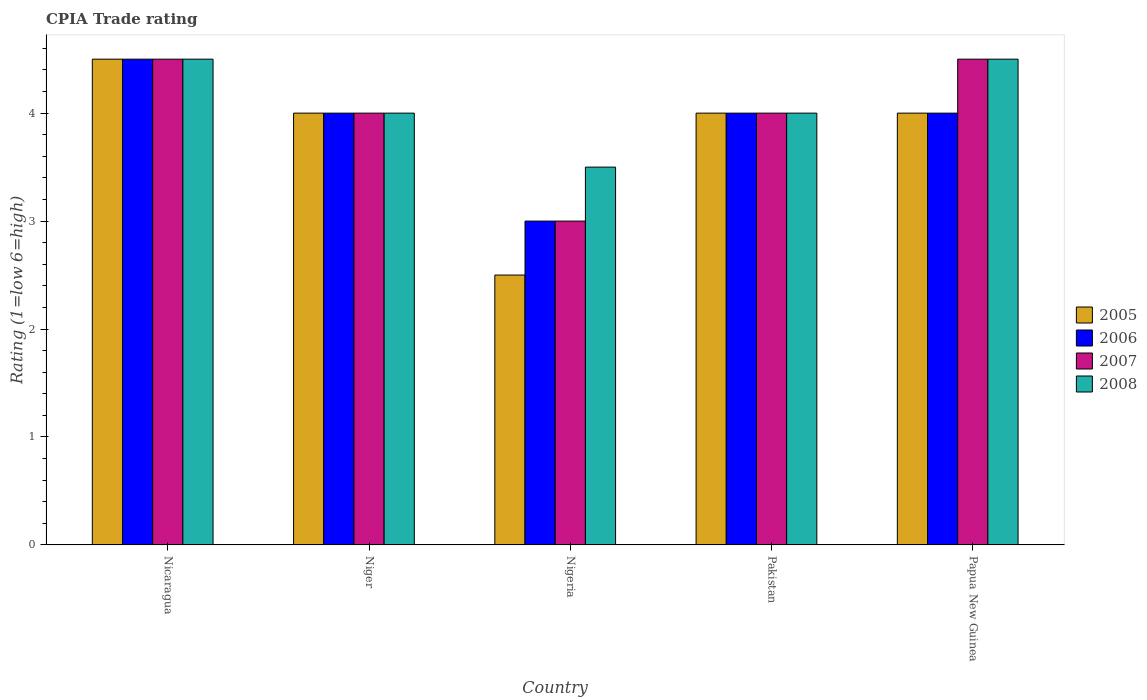How many bars are there on the 1st tick from the left?
Provide a succinct answer. 4. How many bars are there on the 2nd tick from the right?
Keep it short and to the point. 4. What is the label of the 5th group of bars from the left?
Make the answer very short. Papua New Guinea. In how many cases, is the number of bars for a given country not equal to the number of legend labels?
Provide a succinct answer. 0. In which country was the CPIA rating in 2008 maximum?
Make the answer very short. Nicaragua. In which country was the CPIA rating in 2008 minimum?
Give a very brief answer. Nigeria. What is the difference between the CPIA rating in 2006 in Papua New Guinea and the CPIA rating in 2008 in Nicaragua?
Provide a short and direct response. -0.5. What is the difference between the CPIA rating of/in 2006 and CPIA rating of/in 2007 in Pakistan?
Your response must be concise. 0. What is the ratio of the CPIA rating in 2005 in Nicaragua to that in Niger?
Your answer should be very brief. 1.12. Is the difference between the CPIA rating in 2006 in Nicaragua and Niger greater than the difference between the CPIA rating in 2007 in Nicaragua and Niger?
Provide a short and direct response. No. What is the difference between the highest and the second highest CPIA rating in 2007?
Provide a short and direct response. 0.5. In how many countries, is the CPIA rating in 2008 greater than the average CPIA rating in 2008 taken over all countries?
Provide a short and direct response. 2. Is the sum of the CPIA rating in 2005 in Nicaragua and Pakistan greater than the maximum CPIA rating in 2006 across all countries?
Your answer should be very brief. Yes. Is it the case that in every country, the sum of the CPIA rating in 2007 and CPIA rating in 2005 is greater than the sum of CPIA rating in 2008 and CPIA rating in 2006?
Your response must be concise. No. What does the 2nd bar from the left in Pakistan represents?
Your answer should be very brief. 2006. Is it the case that in every country, the sum of the CPIA rating in 2007 and CPIA rating in 2006 is greater than the CPIA rating in 2005?
Provide a succinct answer. Yes. How many bars are there?
Provide a succinct answer. 20. Are all the bars in the graph horizontal?
Ensure brevity in your answer.  No. How many countries are there in the graph?
Give a very brief answer. 5. What is the difference between two consecutive major ticks on the Y-axis?
Your answer should be compact. 1. Are the values on the major ticks of Y-axis written in scientific E-notation?
Offer a terse response. No. Does the graph contain grids?
Your answer should be compact. No. How many legend labels are there?
Offer a terse response. 4. How are the legend labels stacked?
Keep it short and to the point. Vertical. What is the title of the graph?
Offer a very short reply. CPIA Trade rating. Does "2009" appear as one of the legend labels in the graph?
Provide a short and direct response. No. What is the label or title of the Y-axis?
Offer a very short reply. Rating (1=low 6=high). What is the Rating (1=low 6=high) in 2005 in Nicaragua?
Your answer should be very brief. 4.5. What is the Rating (1=low 6=high) of 2006 in Nicaragua?
Make the answer very short. 4.5. What is the Rating (1=low 6=high) in 2008 in Nicaragua?
Your answer should be compact. 4.5. What is the Rating (1=low 6=high) of 2008 in Niger?
Give a very brief answer. 4. What is the Rating (1=low 6=high) of 2005 in Nigeria?
Provide a succinct answer. 2.5. What is the Rating (1=low 6=high) of 2006 in Nigeria?
Provide a succinct answer. 3. What is the Rating (1=low 6=high) in 2007 in Pakistan?
Your answer should be very brief. 4. What is the Rating (1=low 6=high) in 2005 in Papua New Guinea?
Your response must be concise. 4. What is the Rating (1=low 6=high) of 2008 in Papua New Guinea?
Give a very brief answer. 4.5. Across all countries, what is the maximum Rating (1=low 6=high) of 2008?
Your response must be concise. 4.5. Across all countries, what is the minimum Rating (1=low 6=high) of 2006?
Ensure brevity in your answer.  3. Across all countries, what is the minimum Rating (1=low 6=high) of 2008?
Give a very brief answer. 3.5. What is the total Rating (1=low 6=high) in 2008 in the graph?
Give a very brief answer. 20.5. What is the difference between the Rating (1=low 6=high) in 2005 in Nicaragua and that in Niger?
Your answer should be compact. 0.5. What is the difference between the Rating (1=low 6=high) of 2007 in Nicaragua and that in Niger?
Provide a succinct answer. 0.5. What is the difference between the Rating (1=low 6=high) of 2005 in Nicaragua and that in Nigeria?
Make the answer very short. 2. What is the difference between the Rating (1=low 6=high) in 2006 in Nicaragua and that in Nigeria?
Keep it short and to the point. 1.5. What is the difference between the Rating (1=low 6=high) of 2007 in Nicaragua and that in Nigeria?
Your answer should be very brief. 1.5. What is the difference between the Rating (1=low 6=high) in 2008 in Nicaragua and that in Pakistan?
Offer a terse response. 0.5. What is the difference between the Rating (1=low 6=high) of 2008 in Nicaragua and that in Papua New Guinea?
Ensure brevity in your answer.  0. What is the difference between the Rating (1=low 6=high) of 2006 in Niger and that in Nigeria?
Make the answer very short. 1. What is the difference between the Rating (1=low 6=high) in 2007 in Niger and that in Nigeria?
Give a very brief answer. 1. What is the difference between the Rating (1=low 6=high) in 2005 in Niger and that in Pakistan?
Provide a short and direct response. 0. What is the difference between the Rating (1=low 6=high) of 2007 in Niger and that in Pakistan?
Provide a short and direct response. 0. What is the difference between the Rating (1=low 6=high) of 2006 in Niger and that in Papua New Guinea?
Offer a very short reply. 0. What is the difference between the Rating (1=low 6=high) in 2005 in Nigeria and that in Pakistan?
Provide a succinct answer. -1.5. What is the difference between the Rating (1=low 6=high) in 2008 in Nigeria and that in Pakistan?
Give a very brief answer. -0.5. What is the difference between the Rating (1=low 6=high) of 2006 in Nigeria and that in Papua New Guinea?
Your response must be concise. -1. What is the difference between the Rating (1=low 6=high) of 2007 in Pakistan and that in Papua New Guinea?
Provide a succinct answer. -0.5. What is the difference between the Rating (1=low 6=high) in 2005 in Nicaragua and the Rating (1=low 6=high) in 2008 in Niger?
Your answer should be compact. 0.5. What is the difference between the Rating (1=low 6=high) in 2006 in Nicaragua and the Rating (1=low 6=high) in 2008 in Niger?
Your response must be concise. 0.5. What is the difference between the Rating (1=low 6=high) in 2005 in Nicaragua and the Rating (1=low 6=high) in 2006 in Nigeria?
Your response must be concise. 1.5. What is the difference between the Rating (1=low 6=high) of 2006 in Nicaragua and the Rating (1=low 6=high) of 2007 in Nigeria?
Make the answer very short. 1.5. What is the difference between the Rating (1=low 6=high) of 2006 in Nicaragua and the Rating (1=low 6=high) of 2008 in Nigeria?
Give a very brief answer. 1. What is the difference between the Rating (1=low 6=high) in 2007 in Nicaragua and the Rating (1=low 6=high) in 2008 in Nigeria?
Provide a succinct answer. 1. What is the difference between the Rating (1=low 6=high) of 2006 in Nicaragua and the Rating (1=low 6=high) of 2008 in Pakistan?
Your response must be concise. 0.5. What is the difference between the Rating (1=low 6=high) in 2005 in Nicaragua and the Rating (1=low 6=high) in 2006 in Papua New Guinea?
Make the answer very short. 0.5. What is the difference between the Rating (1=low 6=high) in 2005 in Nicaragua and the Rating (1=low 6=high) in 2008 in Papua New Guinea?
Provide a short and direct response. 0. What is the difference between the Rating (1=low 6=high) in 2006 in Nicaragua and the Rating (1=low 6=high) in 2007 in Papua New Guinea?
Provide a succinct answer. 0. What is the difference between the Rating (1=low 6=high) in 2006 in Nicaragua and the Rating (1=low 6=high) in 2008 in Papua New Guinea?
Ensure brevity in your answer.  0. What is the difference between the Rating (1=low 6=high) in 2007 in Nicaragua and the Rating (1=low 6=high) in 2008 in Papua New Guinea?
Your response must be concise. 0. What is the difference between the Rating (1=low 6=high) in 2005 in Niger and the Rating (1=low 6=high) in 2007 in Nigeria?
Keep it short and to the point. 1. What is the difference between the Rating (1=low 6=high) of 2005 in Niger and the Rating (1=low 6=high) of 2008 in Nigeria?
Keep it short and to the point. 0.5. What is the difference between the Rating (1=low 6=high) of 2005 in Niger and the Rating (1=low 6=high) of 2006 in Pakistan?
Your answer should be very brief. 0. What is the difference between the Rating (1=low 6=high) of 2005 in Niger and the Rating (1=low 6=high) of 2007 in Pakistan?
Ensure brevity in your answer.  0. What is the difference between the Rating (1=low 6=high) of 2007 in Niger and the Rating (1=low 6=high) of 2008 in Pakistan?
Make the answer very short. 0. What is the difference between the Rating (1=low 6=high) of 2006 in Niger and the Rating (1=low 6=high) of 2007 in Papua New Guinea?
Your response must be concise. -0.5. What is the difference between the Rating (1=low 6=high) of 2007 in Niger and the Rating (1=low 6=high) of 2008 in Papua New Guinea?
Offer a very short reply. -0.5. What is the difference between the Rating (1=low 6=high) in 2005 in Nigeria and the Rating (1=low 6=high) in 2006 in Pakistan?
Your answer should be compact. -1.5. What is the difference between the Rating (1=low 6=high) in 2005 in Nigeria and the Rating (1=low 6=high) in 2007 in Pakistan?
Your response must be concise. -1.5. What is the difference between the Rating (1=low 6=high) in 2006 in Nigeria and the Rating (1=low 6=high) in 2007 in Pakistan?
Your answer should be compact. -1. What is the difference between the Rating (1=low 6=high) of 2007 in Nigeria and the Rating (1=low 6=high) of 2008 in Pakistan?
Offer a very short reply. -1. What is the difference between the Rating (1=low 6=high) of 2006 in Nigeria and the Rating (1=low 6=high) of 2007 in Papua New Guinea?
Provide a short and direct response. -1.5. What is the difference between the Rating (1=low 6=high) of 2007 in Nigeria and the Rating (1=low 6=high) of 2008 in Papua New Guinea?
Your response must be concise. -1.5. What is the difference between the Rating (1=low 6=high) in 2005 in Pakistan and the Rating (1=low 6=high) in 2007 in Papua New Guinea?
Offer a very short reply. -0.5. What is the difference between the Rating (1=low 6=high) of 2005 in Pakistan and the Rating (1=low 6=high) of 2008 in Papua New Guinea?
Provide a short and direct response. -0.5. What is the difference between the Rating (1=low 6=high) of 2006 in Pakistan and the Rating (1=low 6=high) of 2008 in Papua New Guinea?
Offer a terse response. -0.5. What is the difference between the Rating (1=low 6=high) in 2007 in Pakistan and the Rating (1=low 6=high) in 2008 in Papua New Guinea?
Your response must be concise. -0.5. What is the average Rating (1=low 6=high) in 2006 per country?
Offer a very short reply. 3.9. What is the average Rating (1=low 6=high) of 2007 per country?
Your answer should be very brief. 4. What is the average Rating (1=low 6=high) of 2008 per country?
Provide a succinct answer. 4.1. What is the difference between the Rating (1=low 6=high) of 2005 and Rating (1=low 6=high) of 2006 in Nicaragua?
Ensure brevity in your answer.  0. What is the difference between the Rating (1=low 6=high) in 2006 and Rating (1=low 6=high) in 2007 in Nicaragua?
Your answer should be very brief. 0. What is the difference between the Rating (1=low 6=high) in 2005 and Rating (1=low 6=high) in 2006 in Niger?
Your answer should be very brief. 0. What is the difference between the Rating (1=low 6=high) of 2005 and Rating (1=low 6=high) of 2008 in Niger?
Keep it short and to the point. 0. What is the difference between the Rating (1=low 6=high) of 2006 and Rating (1=low 6=high) of 2007 in Niger?
Make the answer very short. 0. What is the difference between the Rating (1=low 6=high) of 2006 and Rating (1=low 6=high) of 2008 in Niger?
Offer a terse response. 0. What is the difference between the Rating (1=low 6=high) in 2007 and Rating (1=low 6=high) in 2008 in Niger?
Offer a very short reply. 0. What is the difference between the Rating (1=low 6=high) in 2007 and Rating (1=low 6=high) in 2008 in Nigeria?
Your response must be concise. -0.5. What is the difference between the Rating (1=low 6=high) in 2005 and Rating (1=low 6=high) in 2006 in Pakistan?
Provide a succinct answer. 0. What is the difference between the Rating (1=low 6=high) of 2006 and Rating (1=low 6=high) of 2008 in Pakistan?
Your answer should be very brief. 0. What is the difference between the Rating (1=low 6=high) in 2007 and Rating (1=low 6=high) in 2008 in Pakistan?
Your answer should be compact. 0. What is the difference between the Rating (1=low 6=high) of 2006 and Rating (1=low 6=high) of 2007 in Papua New Guinea?
Ensure brevity in your answer.  -0.5. What is the difference between the Rating (1=low 6=high) of 2007 and Rating (1=low 6=high) of 2008 in Papua New Guinea?
Keep it short and to the point. 0. What is the ratio of the Rating (1=low 6=high) in 2006 in Nicaragua to that in Niger?
Your answer should be compact. 1.12. What is the ratio of the Rating (1=low 6=high) of 2005 in Nicaragua to that in Nigeria?
Provide a short and direct response. 1.8. What is the ratio of the Rating (1=low 6=high) of 2006 in Nicaragua to that in Nigeria?
Provide a succinct answer. 1.5. What is the ratio of the Rating (1=low 6=high) of 2008 in Nicaragua to that in Pakistan?
Provide a short and direct response. 1.12. What is the ratio of the Rating (1=low 6=high) in 2005 in Nicaragua to that in Papua New Guinea?
Make the answer very short. 1.12. What is the ratio of the Rating (1=low 6=high) of 2006 in Nicaragua to that in Papua New Guinea?
Make the answer very short. 1.12. What is the ratio of the Rating (1=low 6=high) in 2007 in Nicaragua to that in Papua New Guinea?
Your answer should be compact. 1. What is the ratio of the Rating (1=low 6=high) of 2005 in Niger to that in Nigeria?
Your response must be concise. 1.6. What is the ratio of the Rating (1=low 6=high) of 2006 in Niger to that in Nigeria?
Your answer should be very brief. 1.33. What is the ratio of the Rating (1=low 6=high) of 2007 in Niger to that in Nigeria?
Give a very brief answer. 1.33. What is the ratio of the Rating (1=low 6=high) of 2005 in Niger to that in Pakistan?
Provide a short and direct response. 1. What is the ratio of the Rating (1=low 6=high) of 2006 in Niger to that in Pakistan?
Give a very brief answer. 1. What is the ratio of the Rating (1=low 6=high) in 2007 in Niger to that in Pakistan?
Provide a succinct answer. 1. What is the ratio of the Rating (1=low 6=high) of 2005 in Niger to that in Papua New Guinea?
Keep it short and to the point. 1. What is the ratio of the Rating (1=low 6=high) of 2006 in Niger to that in Papua New Guinea?
Give a very brief answer. 1. What is the ratio of the Rating (1=low 6=high) of 2007 in Niger to that in Papua New Guinea?
Offer a terse response. 0.89. What is the ratio of the Rating (1=low 6=high) of 2005 in Nigeria to that in Pakistan?
Give a very brief answer. 0.62. What is the ratio of the Rating (1=low 6=high) of 2008 in Nigeria to that in Pakistan?
Your response must be concise. 0.88. What is the ratio of the Rating (1=low 6=high) of 2005 in Nigeria to that in Papua New Guinea?
Keep it short and to the point. 0.62. What is the ratio of the Rating (1=low 6=high) of 2006 in Nigeria to that in Papua New Guinea?
Your response must be concise. 0.75. What is the ratio of the Rating (1=low 6=high) in 2006 in Pakistan to that in Papua New Guinea?
Give a very brief answer. 1. What is the ratio of the Rating (1=low 6=high) of 2008 in Pakistan to that in Papua New Guinea?
Your response must be concise. 0.89. What is the difference between the highest and the second highest Rating (1=low 6=high) in 2005?
Ensure brevity in your answer.  0.5. What is the difference between the highest and the lowest Rating (1=low 6=high) of 2005?
Offer a terse response. 2. What is the difference between the highest and the lowest Rating (1=low 6=high) in 2006?
Ensure brevity in your answer.  1.5. What is the difference between the highest and the lowest Rating (1=low 6=high) in 2007?
Offer a terse response. 1.5. 